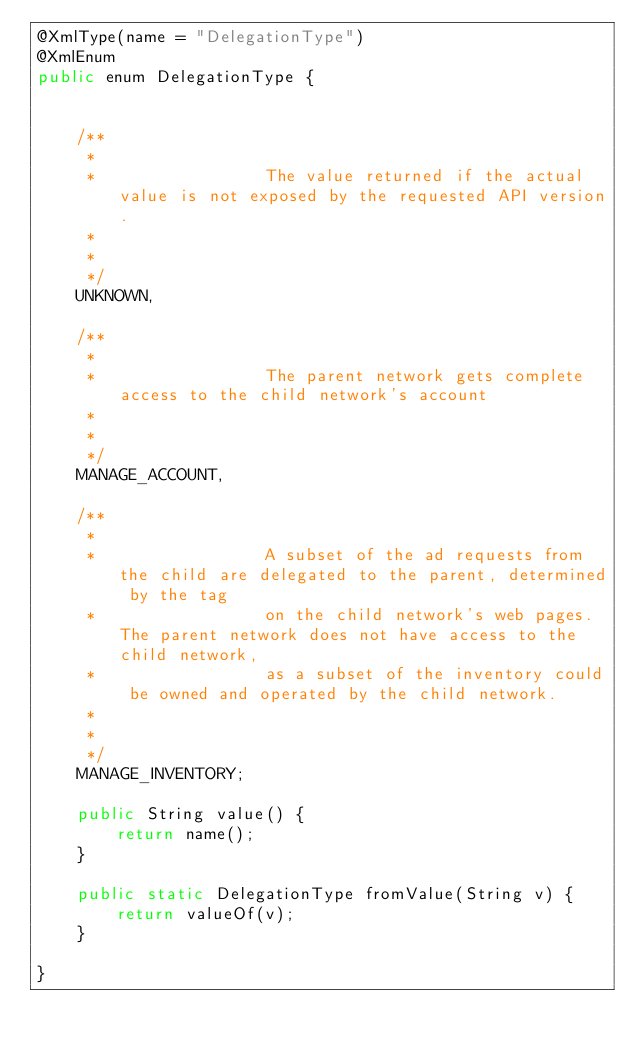Convert code to text. <code><loc_0><loc_0><loc_500><loc_500><_Java_>@XmlType(name = "DelegationType")
@XmlEnum
public enum DelegationType {


    /**
     * 
     *                 The value returned if the actual value is not exposed by the requested API version.
     *               
     * 
     */
    UNKNOWN,

    /**
     * 
     *                 The parent network gets complete access to the child network's account
     *               
     * 
     */
    MANAGE_ACCOUNT,

    /**
     * 
     *                 A subset of the ad requests from the child are delegated to the parent, determined by the tag
     *                 on the child network's web pages. The parent network does not have access to the child network,
     *                 as a subset of the inventory could be owned and operated by the child network.
     *               
     * 
     */
    MANAGE_INVENTORY;

    public String value() {
        return name();
    }

    public static DelegationType fromValue(String v) {
        return valueOf(v);
    }

}
</code> 